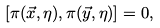<formula> <loc_0><loc_0><loc_500><loc_500>[ \pi ( \vec { x } , \eta ) , \pi ( \vec { y } , \eta ) ] = 0 ,</formula> 